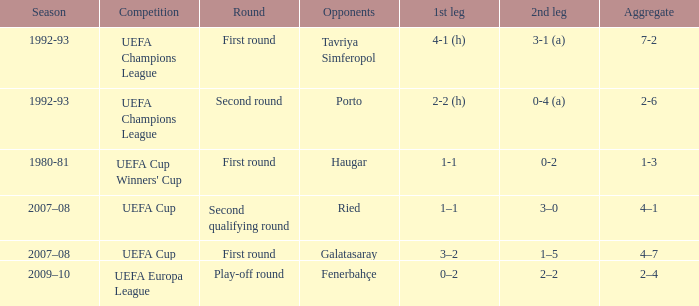What is the total number of 2nd leg where aggregate is 7-2 1.0. 